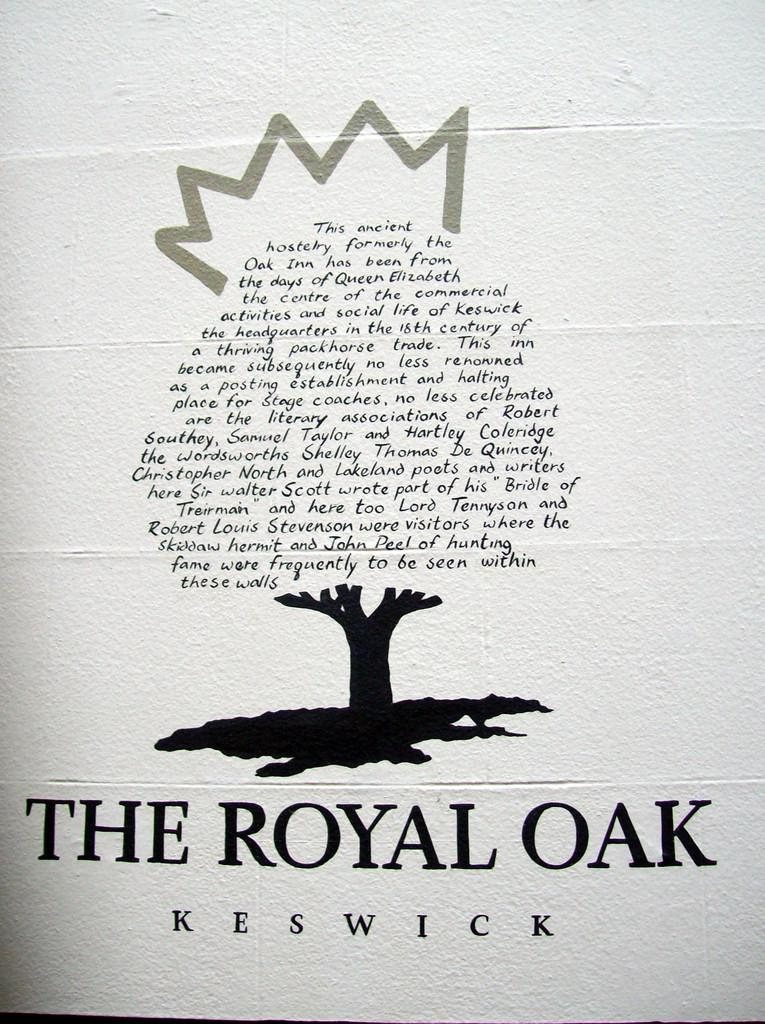<image>
Relay a brief, clear account of the picture shown. A tree made of words over the top of The Royal Oak, Keswick. 